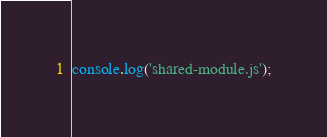<code> <loc_0><loc_0><loc_500><loc_500><_JavaScript_>console.log('shared-module.js');
</code> 